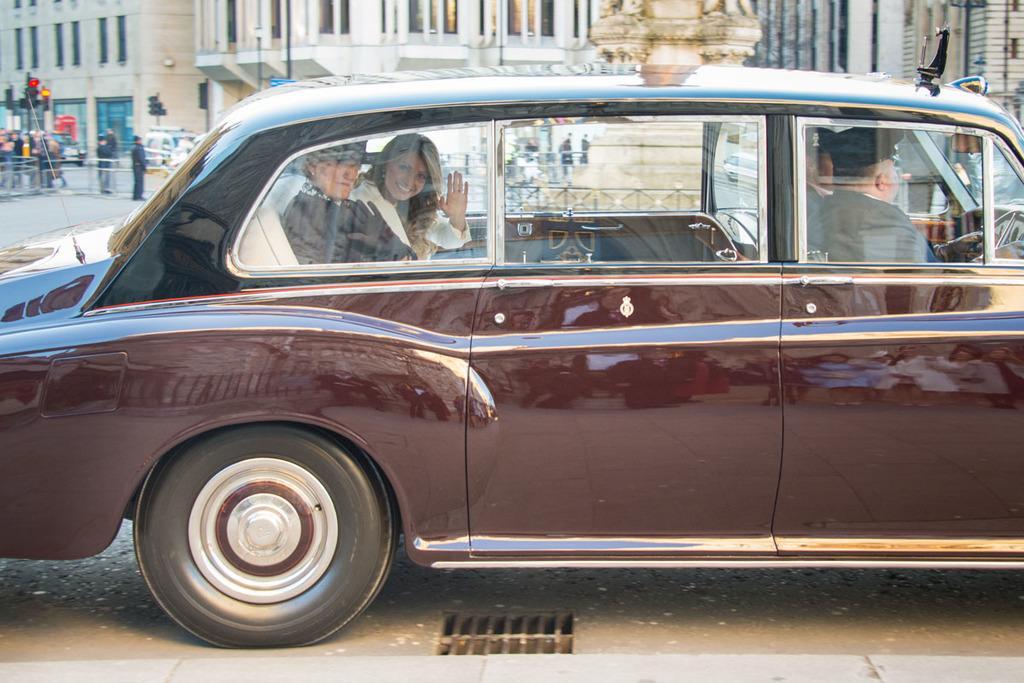Could you give a brief overview of what you see in this image? In this picture there is a brown car, two persons are sitting in the back seat and two persons are sitting in the front seat. one person is holding a steering and he is wearing a black hat and a black shirt. In the backseat, two persons are waving their hand. In the background there are buildings, persons and signal lights. 